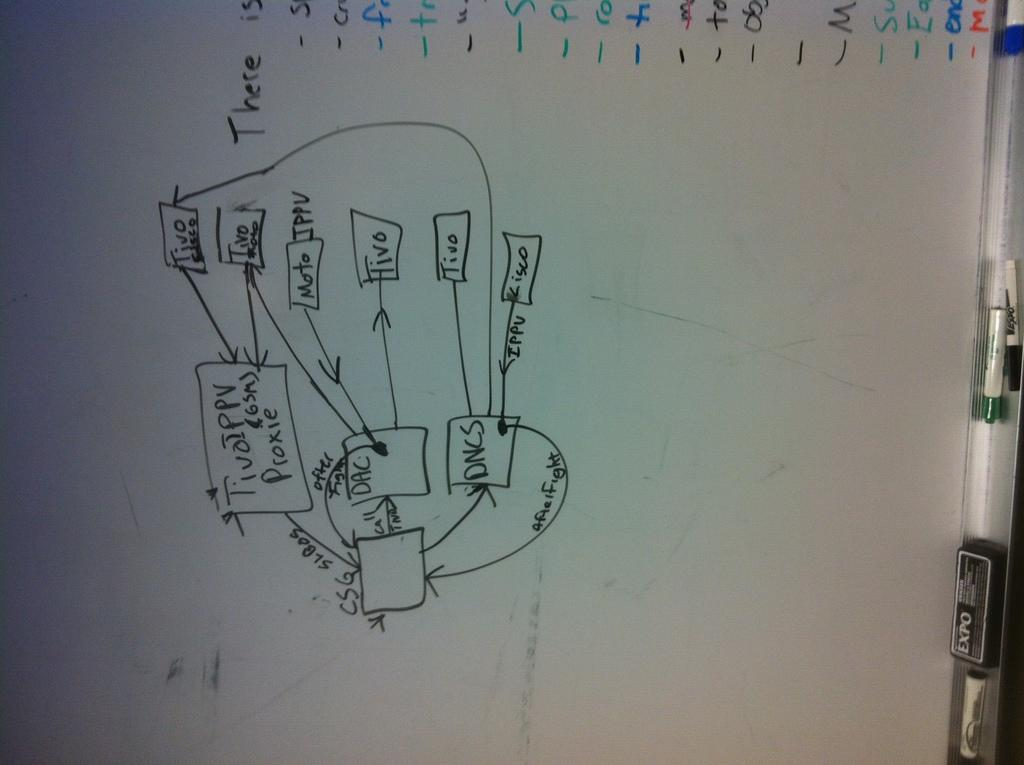<image>
Give a short and clear explanation of the subsequent image. A whiteboard with the word There written on it. 